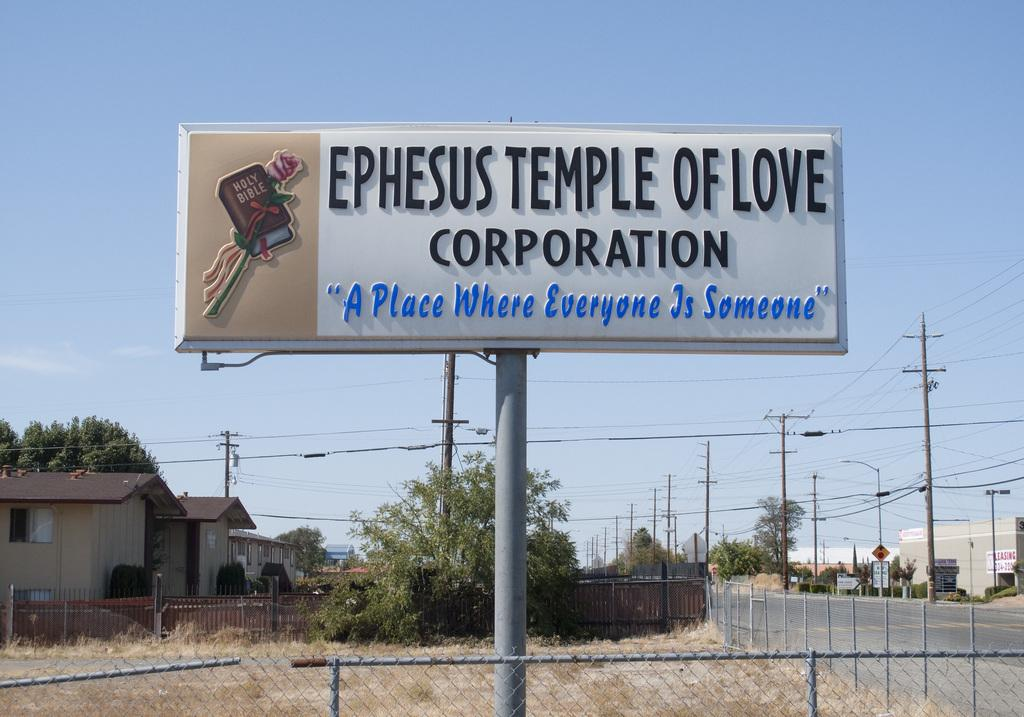<image>
Provide a brief description of the given image. a billboard that says 'ephesus temple of love corporation' on it 